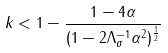<formula> <loc_0><loc_0><loc_500><loc_500>k < 1 - \frac { 1 - 4 \alpha } { ( 1 - 2 \Lambda _ { \sigma } ^ { - 1 } \alpha ^ { 2 } ) ^ { \frac { 1 } { 2 } } }</formula> 